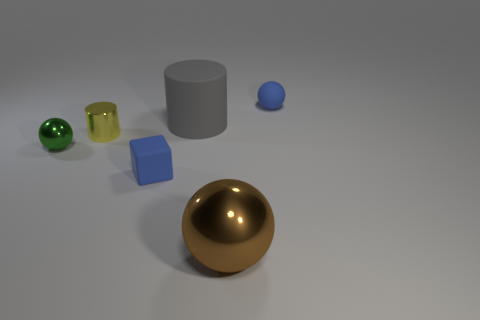Add 4 small green metal cubes. How many objects exist? 10 Subtract all cylinders. How many objects are left? 4 Add 1 big red things. How many big red things exist? 1 Subtract 0 green blocks. How many objects are left? 6 Subtract all metallic spheres. Subtract all tiny yellow cylinders. How many objects are left? 3 Add 4 brown metal spheres. How many brown metal spheres are left? 5 